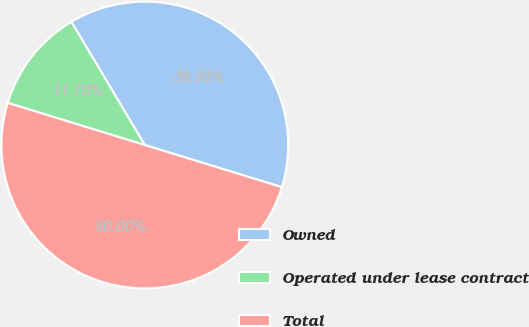Convert chart. <chart><loc_0><loc_0><loc_500><loc_500><pie_chart><fcel>Owned<fcel>Operated under lease contract<fcel>Total<nl><fcel>38.3%<fcel>11.7%<fcel>50.0%<nl></chart> 